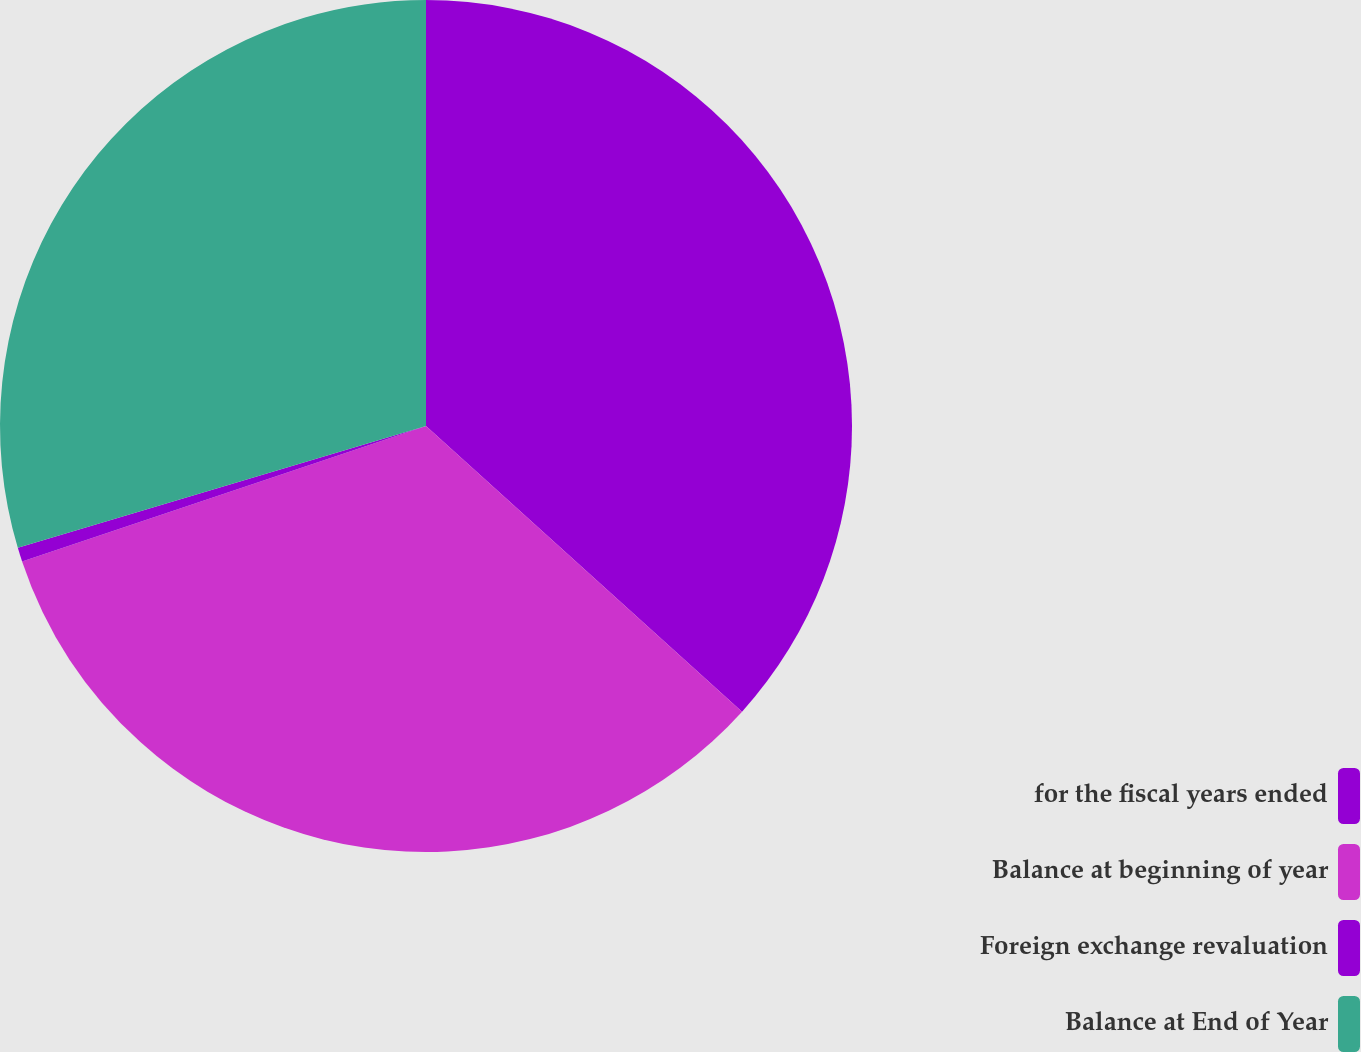Convert chart to OTSL. <chart><loc_0><loc_0><loc_500><loc_500><pie_chart><fcel>for the fiscal years ended<fcel>Balance at beginning of year<fcel>Foreign exchange revaluation<fcel>Balance at End of Year<nl><fcel>36.7%<fcel>33.16%<fcel>0.53%<fcel>29.62%<nl></chart> 